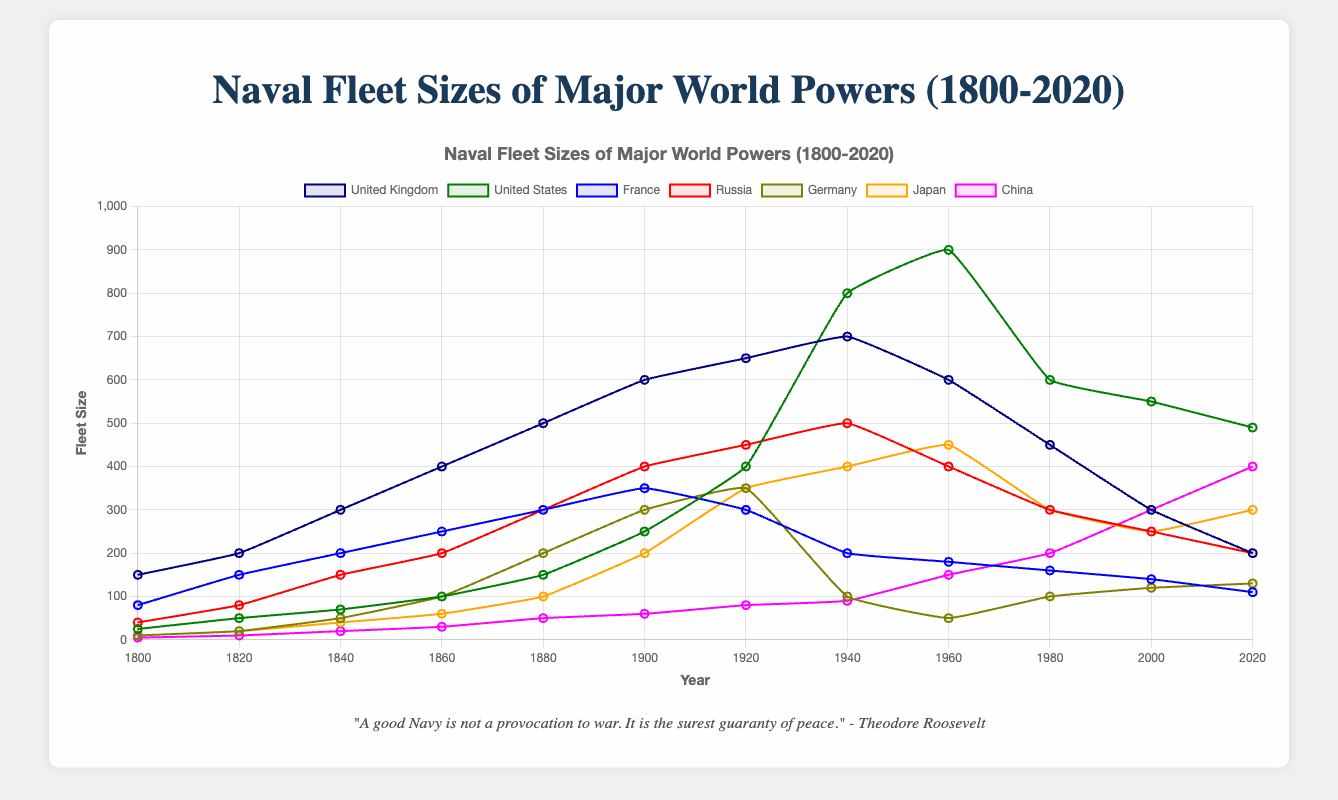Which country's naval fleet size peaked in 1940? By looking at the peaks of each line, identify the year 1940 and check which country's line reaches its highest point at that time. The United Kingdom has the highest value of 700 in 1940.
Answer: United Kingdom What is the difference between the United States' fleet size in 1940 and 2020? From the graph, locate the points corresponding to the United States' fleet size in 1940 and 2020. The values are 800 and 490 respectively. Subtract 490 from 800.
Answer: 310 During which decade did Japan see the largest increase in its fleet size? Identify the steepest upward slope in Japan's line on the graph. The largest increase is between 1920 and 1940, which is the decade following the 1930s.
Answer: 1930s What is the approximate average fleet size of France in the 19th century? The 19th century runs from 1800 to 1899. Locate the values for France from 1800 to 1900 (80, 150, 200, 250, 300, and 350). Calculate the average: (80 + 150 + 200 + 250 + 300 + 350) / 6.
Answer: 222 How does China's fleet size in 2020 compare visually to its size in 1900? Locate the points for China in 1900 and 2020. Visually compare the lengths of the lines at these points. China's fleet size in 2020 is significantly longer, showing a large increase.
Answer: Larger Which two countries had a similar naval fleet size in 2000, approximately 250 ships? Find the 2000 markers for each country. Both Germany and Japan have fleet sizes around 250.
Answer: Germany and Japan What trend in fleet size can be observed for the United Kingdom from 1940 onwards? Identify the pattern of change for the United Kingdom from 1940 to 2020. The trend shows a consistent decline in fleet size.
Answer: Decline Which country had the biggest overall increase in naval fleet size from 1800 to 2020? Compare the changes from 1800 to 2020 by calculating the difference for all countries. The United States increased from 25 to 490, which is the largest increase.
Answer: United States What was the combined naval fleet size of Russia and Germany in 1900? Add the fleet sizes of Russia and Germany in 1900. The values are 400 and 300 respectively, summing up to 700.
Answer: 700 Did any country experience a decrease in fleet size between 2000 and 2020? Check the values for all countries for the years 2000 and 2020. France experienced a decrease from 140 to 110.
Answer: France 